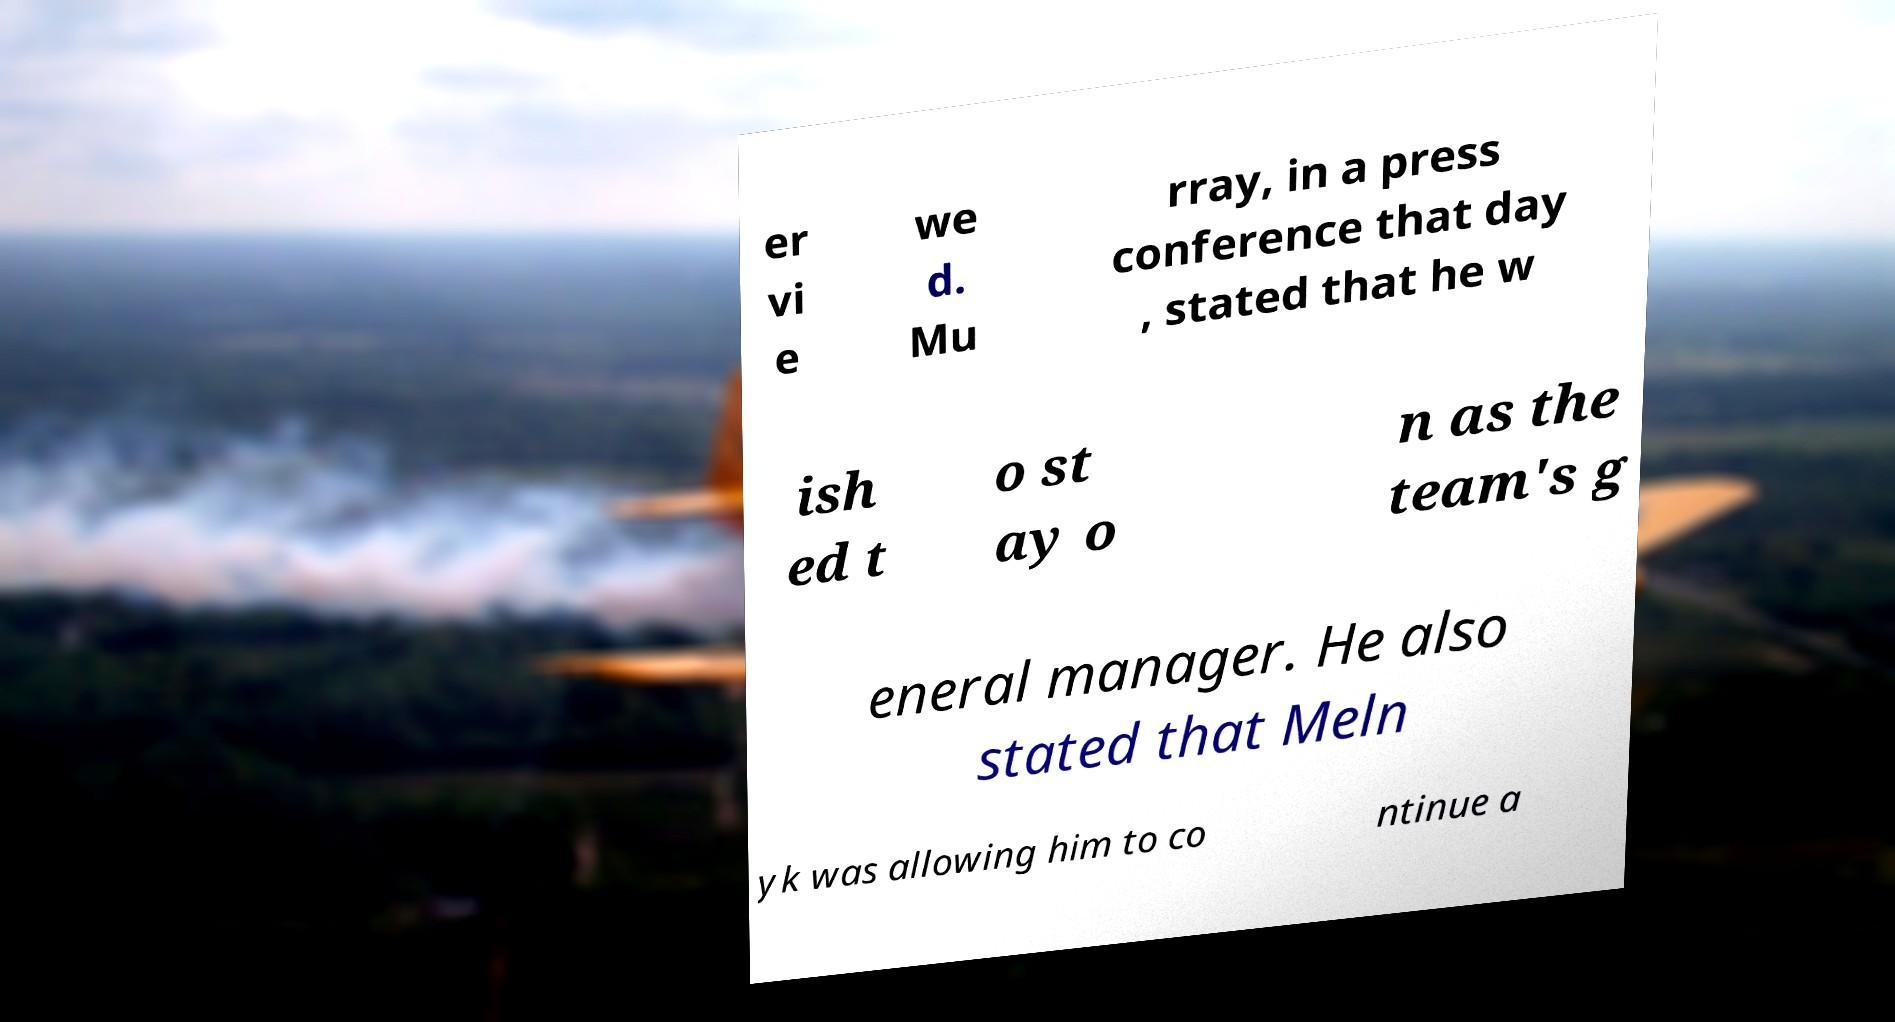There's text embedded in this image that I need extracted. Can you transcribe it verbatim? er vi e we d. Mu rray, in a press conference that day , stated that he w ish ed t o st ay o n as the team's g eneral manager. He also stated that Meln yk was allowing him to co ntinue a 